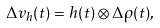Convert formula to latex. <formula><loc_0><loc_0><loc_500><loc_500>\Delta v _ { h } ( t ) = h ( t ) \otimes \Delta \rho ( t ) ,</formula> 